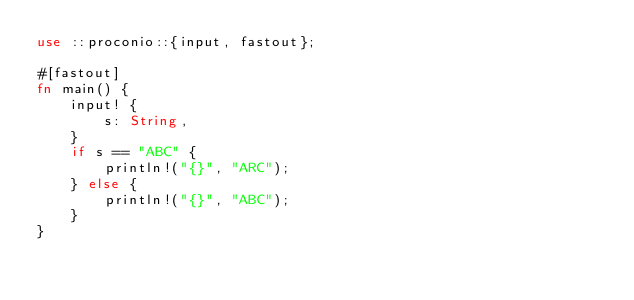Convert code to text. <code><loc_0><loc_0><loc_500><loc_500><_Rust_>use ::proconio::{input, fastout};

#[fastout]
fn main() {
    input! {
        s: String,
    }
    if s == "ABC" {
        println!("{}", "ARC");
    } else {
        println!("{}", "ABC");
    }
}
</code> 